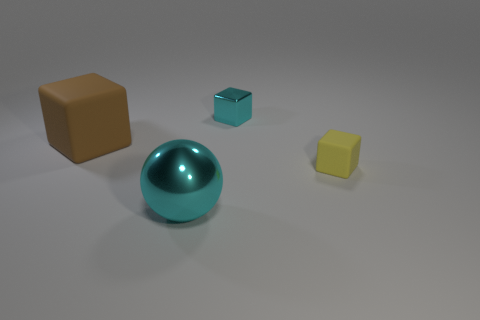Are there any cyan objects that have the same shape as the brown thing?
Give a very brief answer. Yes. Do the cyan thing on the right side of the metal ball and the matte object on the right side of the large brown object have the same shape?
Provide a short and direct response. Yes. What is the material of the thing that is the same size as the cyan ball?
Provide a succinct answer. Rubber. How many other things are the same material as the brown thing?
Your answer should be very brief. 1. The thing in front of the tiny yellow rubber cube that is right of the large ball is what shape?
Your answer should be very brief. Sphere. What number of things are large brown rubber objects or cyan metal things that are to the left of the small metallic object?
Give a very brief answer. 2. How many other things are there of the same color as the big metal ball?
Give a very brief answer. 1. What number of blue objects are large rubber things or small things?
Your answer should be very brief. 0. There is a rubber object to the left of the cyan metal thing that is on the right side of the large sphere; is there a tiny cyan metal cube to the left of it?
Provide a short and direct response. No. Is there anything else that is the same size as the brown matte object?
Your response must be concise. Yes. 